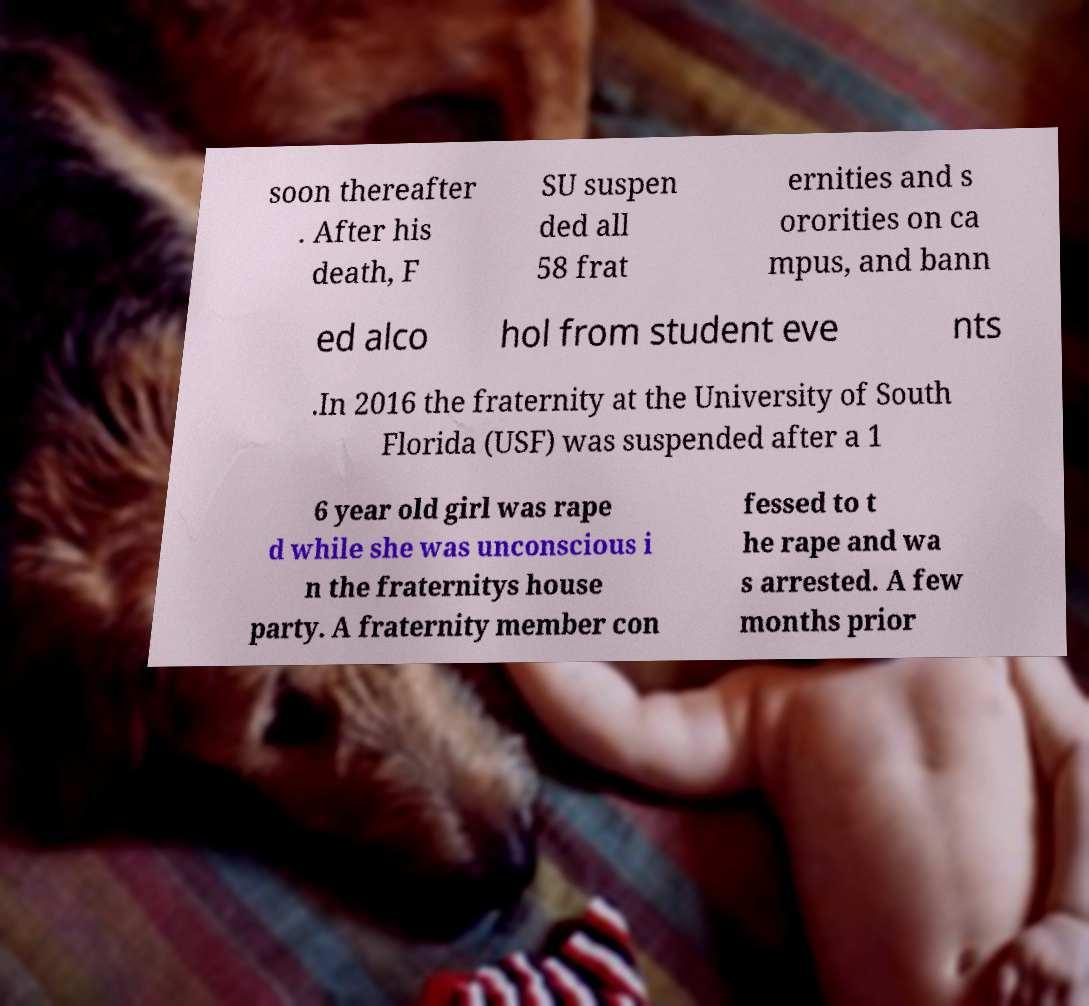Could you assist in decoding the text presented in this image and type it out clearly? soon thereafter . After his death, F SU suspen ded all 58 frat ernities and s ororities on ca mpus, and bann ed alco hol from student eve nts .In 2016 the fraternity at the University of South Florida (USF) was suspended after a 1 6 year old girl was rape d while she was unconscious i n the fraternitys house party. A fraternity member con fessed to t he rape and wa s arrested. A few months prior 